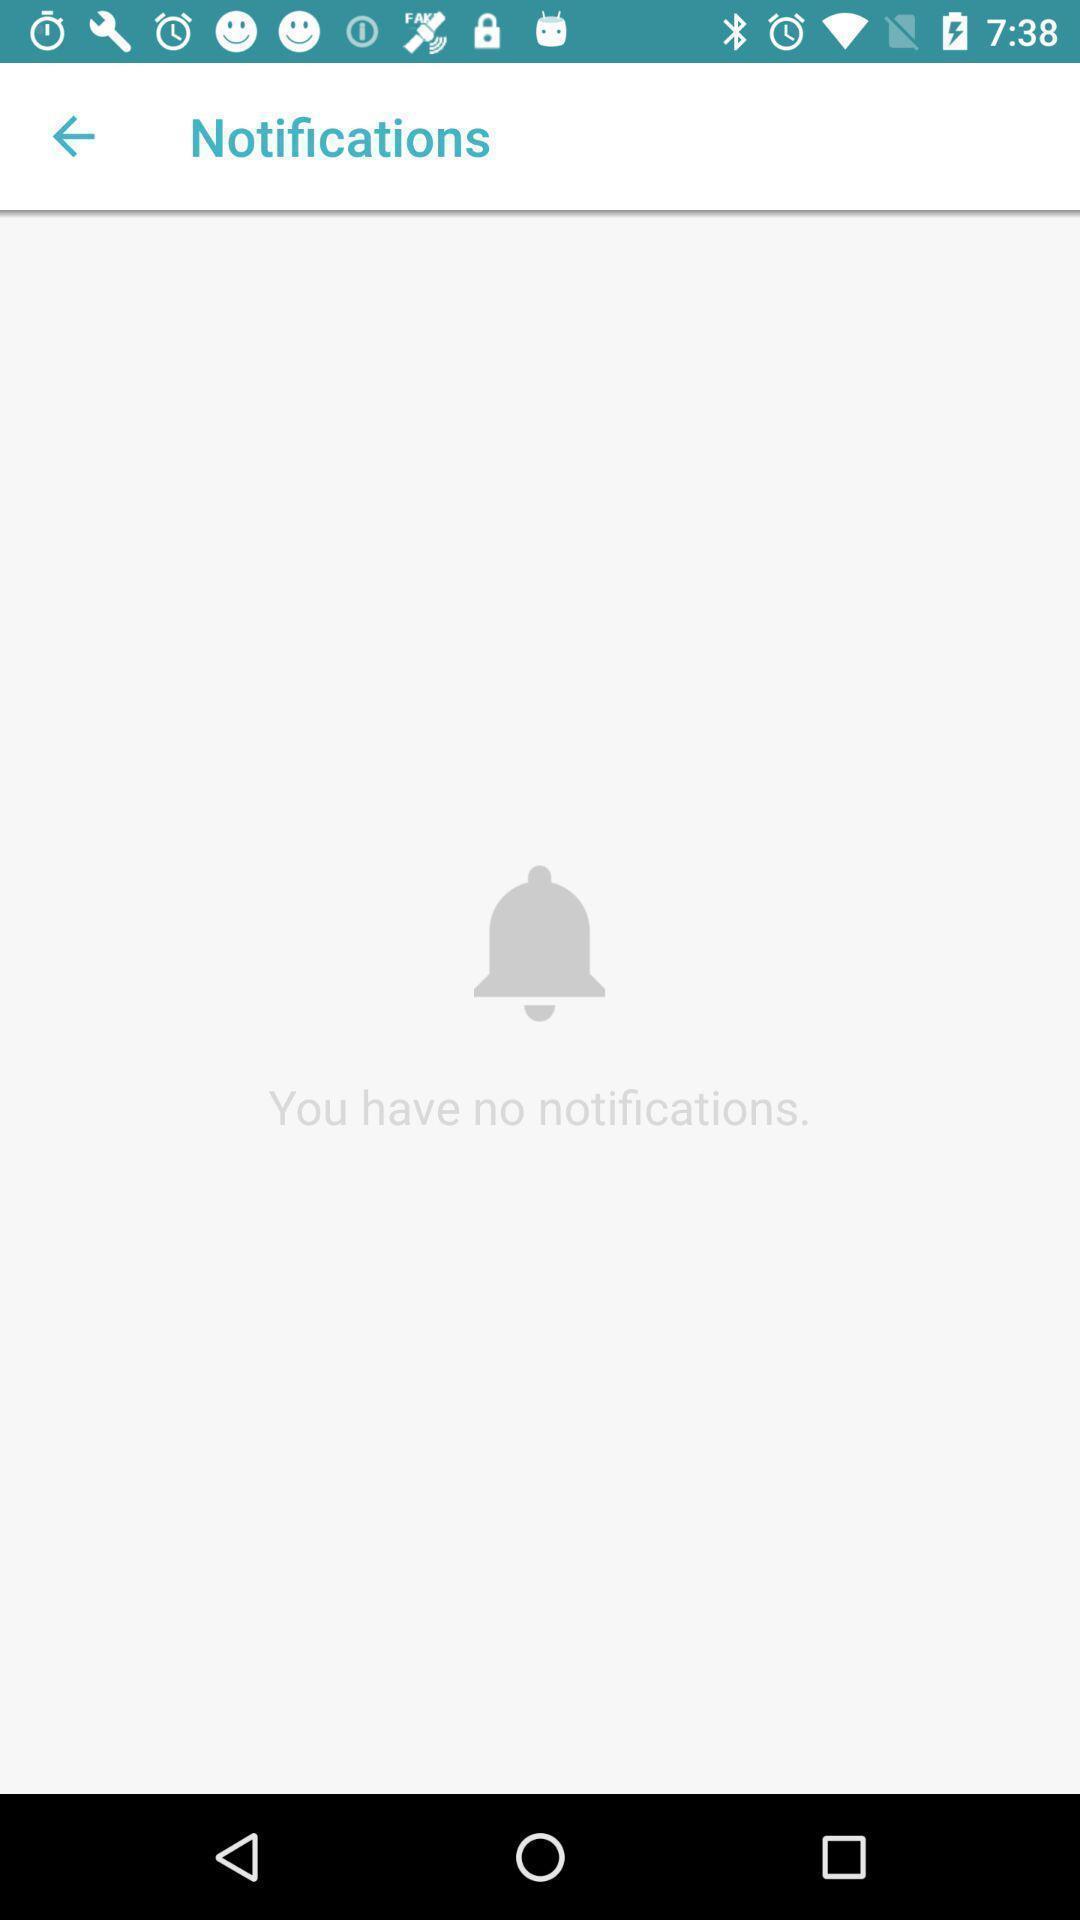Please provide a description for this image. Page displaying the notifications of on app. 